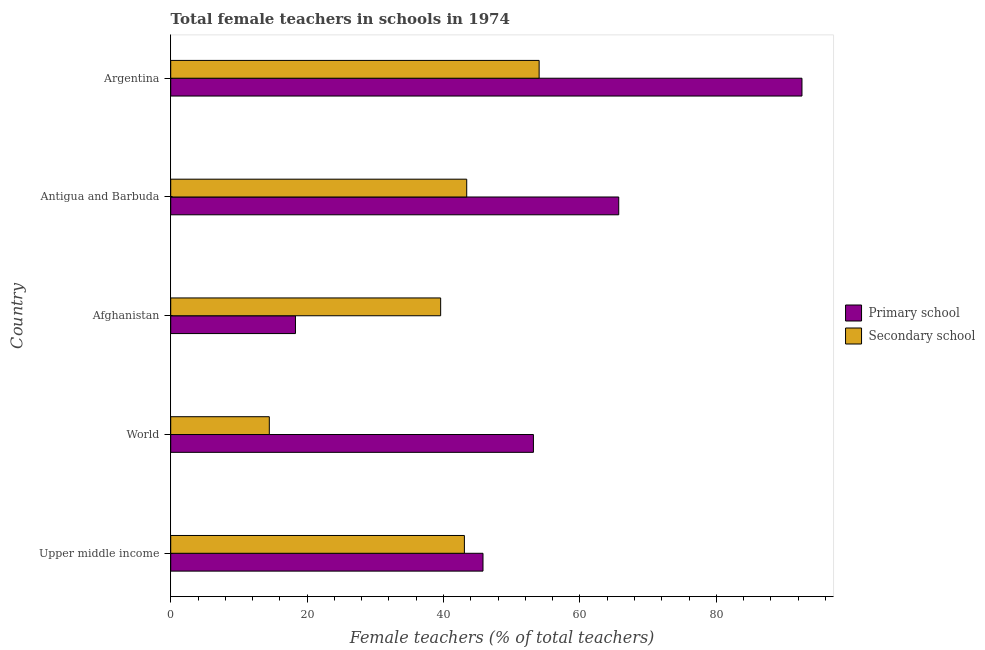How many bars are there on the 2nd tick from the top?
Ensure brevity in your answer.  2. What is the label of the 3rd group of bars from the top?
Your response must be concise. Afghanistan. What is the percentage of female teachers in primary schools in Argentina?
Make the answer very short. 92.55. Across all countries, what is the maximum percentage of female teachers in primary schools?
Ensure brevity in your answer.  92.55. Across all countries, what is the minimum percentage of female teachers in secondary schools?
Offer a very short reply. 14.46. In which country was the percentage of female teachers in secondary schools maximum?
Your answer should be compact. Argentina. In which country was the percentage of female teachers in primary schools minimum?
Give a very brief answer. Afghanistan. What is the total percentage of female teachers in secondary schools in the graph?
Your response must be concise. 194.5. What is the difference between the percentage of female teachers in primary schools in Argentina and that in Upper middle income?
Your response must be concise. 46.76. What is the difference between the percentage of female teachers in primary schools in Argentina and the percentage of female teachers in secondary schools in Afghanistan?
Make the answer very short. 52.97. What is the average percentage of female teachers in secondary schools per country?
Offer a very short reply. 38.9. What is the difference between the percentage of female teachers in primary schools and percentage of female teachers in secondary schools in Afghanistan?
Offer a terse response. -21.29. What is the ratio of the percentage of female teachers in secondary schools in Afghanistan to that in Upper middle income?
Ensure brevity in your answer.  0.92. Is the percentage of female teachers in secondary schools in Antigua and Barbuda less than that in World?
Keep it short and to the point. No. Is the difference between the percentage of female teachers in primary schools in Afghanistan and World greater than the difference between the percentage of female teachers in secondary schools in Afghanistan and World?
Ensure brevity in your answer.  No. What is the difference between the highest and the second highest percentage of female teachers in secondary schools?
Your response must be concise. 10.62. What is the difference between the highest and the lowest percentage of female teachers in secondary schools?
Offer a terse response. 39.56. What does the 2nd bar from the top in Argentina represents?
Give a very brief answer. Primary school. What does the 1st bar from the bottom in World represents?
Provide a short and direct response. Primary school. How many bars are there?
Your answer should be very brief. 10. Are all the bars in the graph horizontal?
Keep it short and to the point. Yes. Does the graph contain any zero values?
Provide a short and direct response. No. Does the graph contain grids?
Give a very brief answer. No. What is the title of the graph?
Ensure brevity in your answer.  Total female teachers in schools in 1974. What is the label or title of the X-axis?
Ensure brevity in your answer.  Female teachers (% of total teachers). What is the label or title of the Y-axis?
Offer a very short reply. Country. What is the Female teachers (% of total teachers) in Primary school in Upper middle income?
Give a very brief answer. 45.78. What is the Female teachers (% of total teachers) of Secondary school in Upper middle income?
Offer a terse response. 43.06. What is the Female teachers (% of total teachers) in Primary school in World?
Make the answer very short. 53.18. What is the Female teachers (% of total teachers) of Secondary school in World?
Provide a short and direct response. 14.46. What is the Female teachers (% of total teachers) in Primary school in Afghanistan?
Give a very brief answer. 18.29. What is the Female teachers (% of total teachers) of Secondary school in Afghanistan?
Offer a terse response. 39.58. What is the Female teachers (% of total teachers) of Primary school in Antigua and Barbuda?
Give a very brief answer. 65.68. What is the Female teachers (% of total teachers) of Secondary school in Antigua and Barbuda?
Offer a terse response. 43.4. What is the Female teachers (% of total teachers) of Primary school in Argentina?
Make the answer very short. 92.55. What is the Female teachers (% of total teachers) in Secondary school in Argentina?
Make the answer very short. 54.01. Across all countries, what is the maximum Female teachers (% of total teachers) of Primary school?
Provide a succinct answer. 92.55. Across all countries, what is the maximum Female teachers (% of total teachers) in Secondary school?
Provide a short and direct response. 54.01. Across all countries, what is the minimum Female teachers (% of total teachers) of Primary school?
Provide a short and direct response. 18.29. Across all countries, what is the minimum Female teachers (% of total teachers) in Secondary school?
Your answer should be compact. 14.46. What is the total Female teachers (% of total teachers) of Primary school in the graph?
Your answer should be very brief. 275.48. What is the total Female teachers (% of total teachers) in Secondary school in the graph?
Keep it short and to the point. 194.5. What is the difference between the Female teachers (% of total teachers) in Primary school in Upper middle income and that in World?
Give a very brief answer. -7.39. What is the difference between the Female teachers (% of total teachers) of Secondary school in Upper middle income and that in World?
Your response must be concise. 28.6. What is the difference between the Female teachers (% of total teachers) in Primary school in Upper middle income and that in Afghanistan?
Your response must be concise. 27.49. What is the difference between the Female teachers (% of total teachers) in Secondary school in Upper middle income and that in Afghanistan?
Offer a very short reply. 3.48. What is the difference between the Female teachers (% of total teachers) of Primary school in Upper middle income and that in Antigua and Barbuda?
Keep it short and to the point. -19.9. What is the difference between the Female teachers (% of total teachers) in Secondary school in Upper middle income and that in Antigua and Barbuda?
Your response must be concise. -0.34. What is the difference between the Female teachers (% of total teachers) in Primary school in Upper middle income and that in Argentina?
Your answer should be compact. -46.76. What is the difference between the Female teachers (% of total teachers) of Secondary school in Upper middle income and that in Argentina?
Give a very brief answer. -10.96. What is the difference between the Female teachers (% of total teachers) in Primary school in World and that in Afghanistan?
Make the answer very short. 34.89. What is the difference between the Female teachers (% of total teachers) in Secondary school in World and that in Afghanistan?
Make the answer very short. -25.12. What is the difference between the Female teachers (% of total teachers) of Primary school in World and that in Antigua and Barbuda?
Your answer should be very brief. -12.51. What is the difference between the Female teachers (% of total teachers) in Secondary school in World and that in Antigua and Barbuda?
Provide a succinct answer. -28.94. What is the difference between the Female teachers (% of total teachers) of Primary school in World and that in Argentina?
Your response must be concise. -39.37. What is the difference between the Female teachers (% of total teachers) in Secondary school in World and that in Argentina?
Make the answer very short. -39.56. What is the difference between the Female teachers (% of total teachers) of Primary school in Afghanistan and that in Antigua and Barbuda?
Offer a very short reply. -47.39. What is the difference between the Female teachers (% of total teachers) of Secondary school in Afghanistan and that in Antigua and Barbuda?
Give a very brief answer. -3.82. What is the difference between the Female teachers (% of total teachers) of Primary school in Afghanistan and that in Argentina?
Keep it short and to the point. -74.26. What is the difference between the Female teachers (% of total teachers) of Secondary school in Afghanistan and that in Argentina?
Make the answer very short. -14.44. What is the difference between the Female teachers (% of total teachers) of Primary school in Antigua and Barbuda and that in Argentina?
Ensure brevity in your answer.  -26.87. What is the difference between the Female teachers (% of total teachers) of Secondary school in Antigua and Barbuda and that in Argentina?
Provide a succinct answer. -10.62. What is the difference between the Female teachers (% of total teachers) of Primary school in Upper middle income and the Female teachers (% of total teachers) of Secondary school in World?
Give a very brief answer. 31.33. What is the difference between the Female teachers (% of total teachers) in Primary school in Upper middle income and the Female teachers (% of total teachers) in Secondary school in Afghanistan?
Your answer should be compact. 6.21. What is the difference between the Female teachers (% of total teachers) of Primary school in Upper middle income and the Female teachers (% of total teachers) of Secondary school in Antigua and Barbuda?
Your answer should be compact. 2.39. What is the difference between the Female teachers (% of total teachers) in Primary school in Upper middle income and the Female teachers (% of total teachers) in Secondary school in Argentina?
Your answer should be compact. -8.23. What is the difference between the Female teachers (% of total teachers) of Primary school in World and the Female teachers (% of total teachers) of Secondary school in Afghanistan?
Make the answer very short. 13.6. What is the difference between the Female teachers (% of total teachers) of Primary school in World and the Female teachers (% of total teachers) of Secondary school in Antigua and Barbuda?
Keep it short and to the point. 9.78. What is the difference between the Female teachers (% of total teachers) in Primary school in World and the Female teachers (% of total teachers) in Secondary school in Argentina?
Your answer should be compact. -0.84. What is the difference between the Female teachers (% of total teachers) of Primary school in Afghanistan and the Female teachers (% of total teachers) of Secondary school in Antigua and Barbuda?
Provide a short and direct response. -25.11. What is the difference between the Female teachers (% of total teachers) of Primary school in Afghanistan and the Female teachers (% of total teachers) of Secondary school in Argentina?
Your response must be concise. -35.73. What is the difference between the Female teachers (% of total teachers) in Primary school in Antigua and Barbuda and the Female teachers (% of total teachers) in Secondary school in Argentina?
Make the answer very short. 11.67. What is the average Female teachers (% of total teachers) in Primary school per country?
Keep it short and to the point. 55.1. What is the average Female teachers (% of total teachers) in Secondary school per country?
Your answer should be very brief. 38.9. What is the difference between the Female teachers (% of total teachers) of Primary school and Female teachers (% of total teachers) of Secondary school in Upper middle income?
Ensure brevity in your answer.  2.73. What is the difference between the Female teachers (% of total teachers) in Primary school and Female teachers (% of total teachers) in Secondary school in World?
Offer a very short reply. 38.72. What is the difference between the Female teachers (% of total teachers) of Primary school and Female teachers (% of total teachers) of Secondary school in Afghanistan?
Provide a short and direct response. -21.29. What is the difference between the Female teachers (% of total teachers) of Primary school and Female teachers (% of total teachers) of Secondary school in Antigua and Barbuda?
Offer a terse response. 22.29. What is the difference between the Female teachers (% of total teachers) in Primary school and Female teachers (% of total teachers) in Secondary school in Argentina?
Your answer should be very brief. 38.53. What is the ratio of the Female teachers (% of total teachers) of Primary school in Upper middle income to that in World?
Your answer should be compact. 0.86. What is the ratio of the Female teachers (% of total teachers) of Secondary school in Upper middle income to that in World?
Your answer should be very brief. 2.98. What is the ratio of the Female teachers (% of total teachers) in Primary school in Upper middle income to that in Afghanistan?
Offer a terse response. 2.5. What is the ratio of the Female teachers (% of total teachers) of Secondary school in Upper middle income to that in Afghanistan?
Your answer should be very brief. 1.09. What is the ratio of the Female teachers (% of total teachers) in Primary school in Upper middle income to that in Antigua and Barbuda?
Your response must be concise. 0.7. What is the ratio of the Female teachers (% of total teachers) of Primary school in Upper middle income to that in Argentina?
Offer a terse response. 0.49. What is the ratio of the Female teachers (% of total teachers) in Secondary school in Upper middle income to that in Argentina?
Keep it short and to the point. 0.8. What is the ratio of the Female teachers (% of total teachers) in Primary school in World to that in Afghanistan?
Your response must be concise. 2.91. What is the ratio of the Female teachers (% of total teachers) of Secondary school in World to that in Afghanistan?
Make the answer very short. 0.37. What is the ratio of the Female teachers (% of total teachers) of Primary school in World to that in Antigua and Barbuda?
Offer a terse response. 0.81. What is the ratio of the Female teachers (% of total teachers) of Secondary school in World to that in Antigua and Barbuda?
Provide a succinct answer. 0.33. What is the ratio of the Female teachers (% of total teachers) in Primary school in World to that in Argentina?
Offer a terse response. 0.57. What is the ratio of the Female teachers (% of total teachers) in Secondary school in World to that in Argentina?
Offer a very short reply. 0.27. What is the ratio of the Female teachers (% of total teachers) in Primary school in Afghanistan to that in Antigua and Barbuda?
Make the answer very short. 0.28. What is the ratio of the Female teachers (% of total teachers) in Secondary school in Afghanistan to that in Antigua and Barbuda?
Give a very brief answer. 0.91. What is the ratio of the Female teachers (% of total teachers) of Primary school in Afghanistan to that in Argentina?
Offer a very short reply. 0.2. What is the ratio of the Female teachers (% of total teachers) in Secondary school in Afghanistan to that in Argentina?
Give a very brief answer. 0.73. What is the ratio of the Female teachers (% of total teachers) in Primary school in Antigua and Barbuda to that in Argentina?
Offer a terse response. 0.71. What is the ratio of the Female teachers (% of total teachers) in Secondary school in Antigua and Barbuda to that in Argentina?
Your answer should be compact. 0.8. What is the difference between the highest and the second highest Female teachers (% of total teachers) of Primary school?
Give a very brief answer. 26.87. What is the difference between the highest and the second highest Female teachers (% of total teachers) of Secondary school?
Offer a terse response. 10.62. What is the difference between the highest and the lowest Female teachers (% of total teachers) in Primary school?
Make the answer very short. 74.26. What is the difference between the highest and the lowest Female teachers (% of total teachers) of Secondary school?
Your response must be concise. 39.56. 